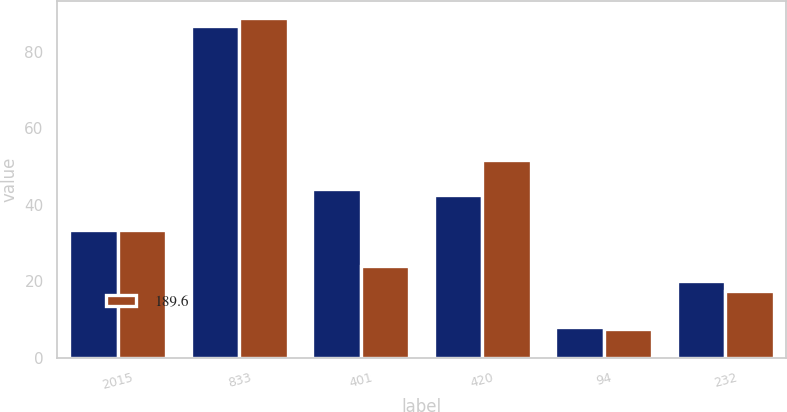Convert chart. <chart><loc_0><loc_0><loc_500><loc_500><stacked_bar_chart><ecel><fcel>2015<fcel>833<fcel>401<fcel>420<fcel>94<fcel>232<nl><fcel>nan<fcel>33.35<fcel>86.7<fcel>44.2<fcel>42.6<fcel>8.2<fcel>20.1<nl><fcel>189.6<fcel>33.35<fcel>88.8<fcel>24.1<fcel>51.7<fcel>7.5<fcel>17.5<nl></chart> 